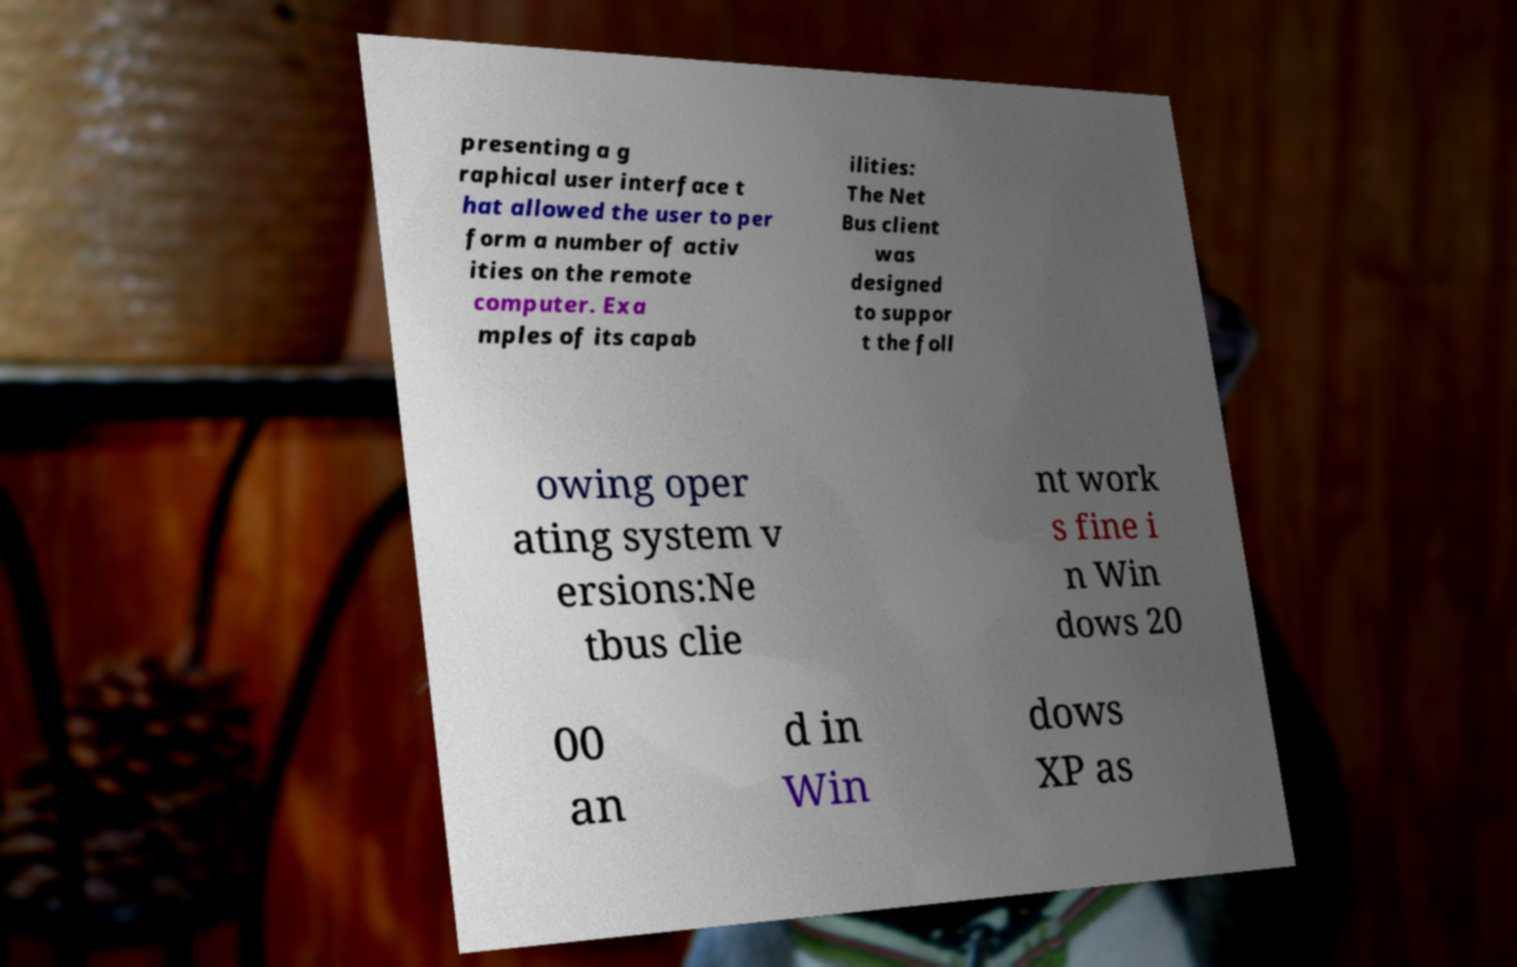Can you accurately transcribe the text from the provided image for me? presenting a g raphical user interface t hat allowed the user to per form a number of activ ities on the remote computer. Exa mples of its capab ilities: The Net Bus client was designed to suppor t the foll owing oper ating system v ersions:Ne tbus clie nt work s fine i n Win dows 20 00 an d in Win dows XP as 